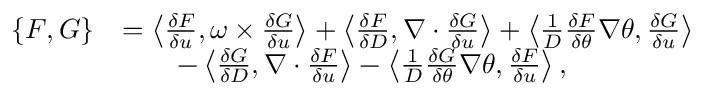<formula> <loc_0><loc_0><loc_500><loc_500>\begin{array} { r l } { \{ F , G \} } & { = \left \langle \frac { \delta F } { \delta u } , \omega \times \frac { \delta G } { \delta u } \right \rangle + \left \langle \frac { \delta F } { \delta D } , \nabla \cdot \frac { \delta G } { \delta u } \right \rangle + \left \langle \frac { 1 } { D } \frac { \delta F } { \delta \theta } \nabla \theta , \frac { \delta G } { \delta u } \right \rangle } \\ & { \quad - \left \langle \frac { \delta G } { \delta D } , \nabla \cdot \frac { \delta F } { \delta u } \right \rangle - \left \langle \frac { 1 } { D } \frac { \delta G } { \delta \theta } \nabla \theta , \frac { \delta F } { \delta u } \right \rangle , } \end{array}</formula> 